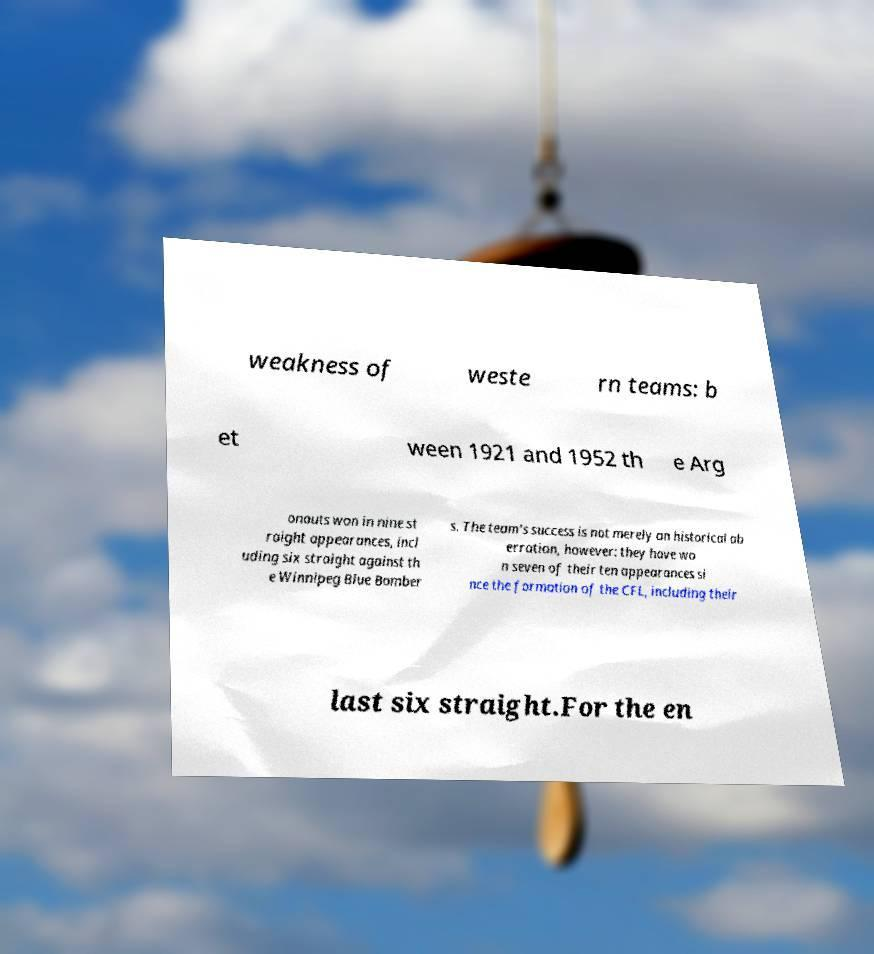There's text embedded in this image that I need extracted. Can you transcribe it verbatim? weakness of weste rn teams: b et ween 1921 and 1952 th e Arg onauts won in nine st raight appearances, incl uding six straight against th e Winnipeg Blue Bomber s. The team's success is not merely an historical ab erration, however: they have wo n seven of their ten appearances si nce the formation of the CFL, including their last six straight.For the en 